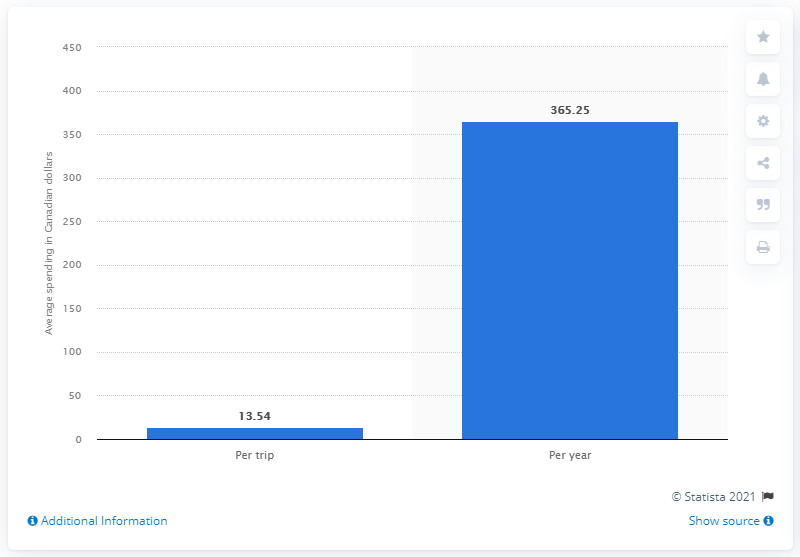Give some essential details in this illustration. Canadians spent an estimated $365.25 million in dollar stores in a year. 